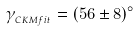Convert formula to latex. <formula><loc_0><loc_0><loc_500><loc_500>\gamma _ { _ { C K M f i t } } = ( 5 6 \pm 8 ) ^ { \circ }</formula> 